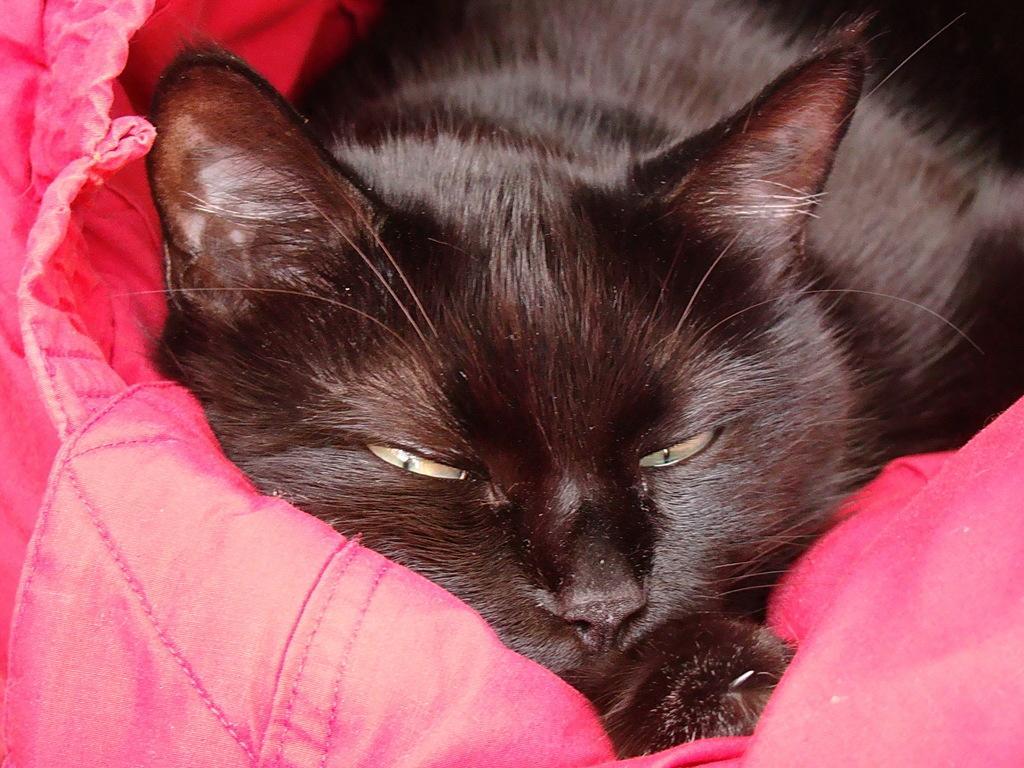In one or two sentences, can you explain what this image depicts? In the picture we can see a cat which is black in color lying on the pink color blanket. 